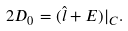Convert formula to latex. <formula><loc_0><loc_0><loc_500><loc_500>2 D _ { 0 } = ( \hat { l } + E ) | _ { C } .</formula> 